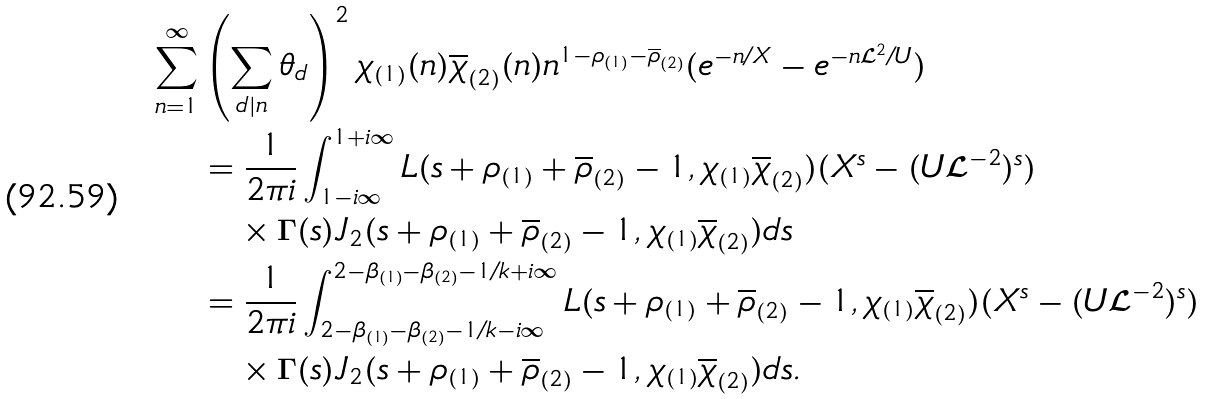Convert formula to latex. <formula><loc_0><loc_0><loc_500><loc_500>\sum _ { n = 1 } ^ { \infty } & \left ( \sum _ { d | n } \theta _ { d } \right ) ^ { 2 } \chi _ { ( 1 ) } ( n ) \overline { \chi } _ { ( 2 ) } ( n ) n ^ { 1 - \rho _ { ( 1 ) } - \overline { \rho } _ { ( 2 ) } } ( e ^ { - n / X } - e ^ { - n \mathcal { L } ^ { 2 } / U } ) \\ & = \frac { 1 } { 2 \pi i } \int ^ { 1 + i \infty } _ { 1 - i \infty } L ( s + \rho _ { ( 1 ) } + \overline { \rho } _ { ( 2 ) } - 1 , \chi _ { ( 1 ) } \overline { \chi } _ { ( 2 ) } ) ( X ^ { s } - ( U \mathcal { L } ^ { - 2 } ) ^ { s } ) \\ & \quad \times \Gamma ( s ) J _ { 2 } ( s + \rho _ { ( 1 ) } + \overline { \rho } _ { ( 2 ) } - 1 , \chi _ { ( 1 ) } \overline { \chi } _ { ( 2 ) } ) d s \\ & = \frac { 1 } { 2 \pi i } \int ^ { 2 - \beta _ { ( 1 ) } - \beta _ { ( 2 ) } - 1 / k + i \infty } _ { 2 - \beta _ { ( 1 ) } - \beta _ { ( 2 ) } - 1 / k - i \infty } L ( s + \rho _ { ( 1 ) } + \overline { \rho } _ { ( 2 ) } - 1 , \chi _ { ( 1 ) } \overline { \chi } _ { ( 2 ) } ) ( X ^ { s } - ( U \mathcal { L } ^ { - 2 } ) ^ { s } ) \\ & \quad \times \Gamma ( s ) J _ { 2 } ( s + \rho _ { ( 1 ) } + \overline { \rho } _ { ( 2 ) } - 1 , \chi _ { ( 1 ) } \overline { \chi } _ { ( 2 ) } ) d s .</formula> 